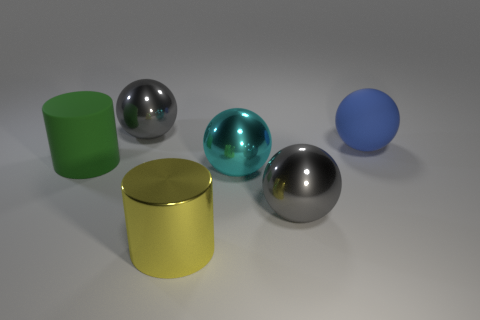What number of large yellow cylinders are in front of the matte cylinder?
Offer a terse response. 1. Are the large yellow thing and the large cylinder to the left of the yellow cylinder made of the same material?
Offer a terse response. No. Are the green cylinder and the blue object made of the same material?
Provide a succinct answer. Yes. There is a gray shiny sphere in front of the green matte cylinder; are there any cyan metal objects that are to the right of it?
Give a very brief answer. No. How many big balls are both behind the large green cylinder and in front of the big green matte object?
Keep it short and to the point. 0. There is a big yellow shiny object that is to the left of the big cyan sphere; what is its shape?
Provide a succinct answer. Cylinder. What number of gray balls are the same size as the yellow thing?
Ensure brevity in your answer.  2. There is a ball that is right of the big cyan ball and in front of the big rubber cylinder; what material is it?
Provide a succinct answer. Metal. Is the number of large rubber things greater than the number of metallic balls?
Provide a short and direct response. No. What is the color of the matte object that is right of the gray sphere in front of the large gray thing on the left side of the shiny cylinder?
Your response must be concise. Blue. 